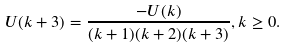Convert formula to latex. <formula><loc_0><loc_0><loc_500><loc_500>U ( k + 3 ) = \frac { - U ( k ) } { ( k + 1 ) ( k + 2 ) ( k + 3 ) } , k \geq 0 .</formula> 